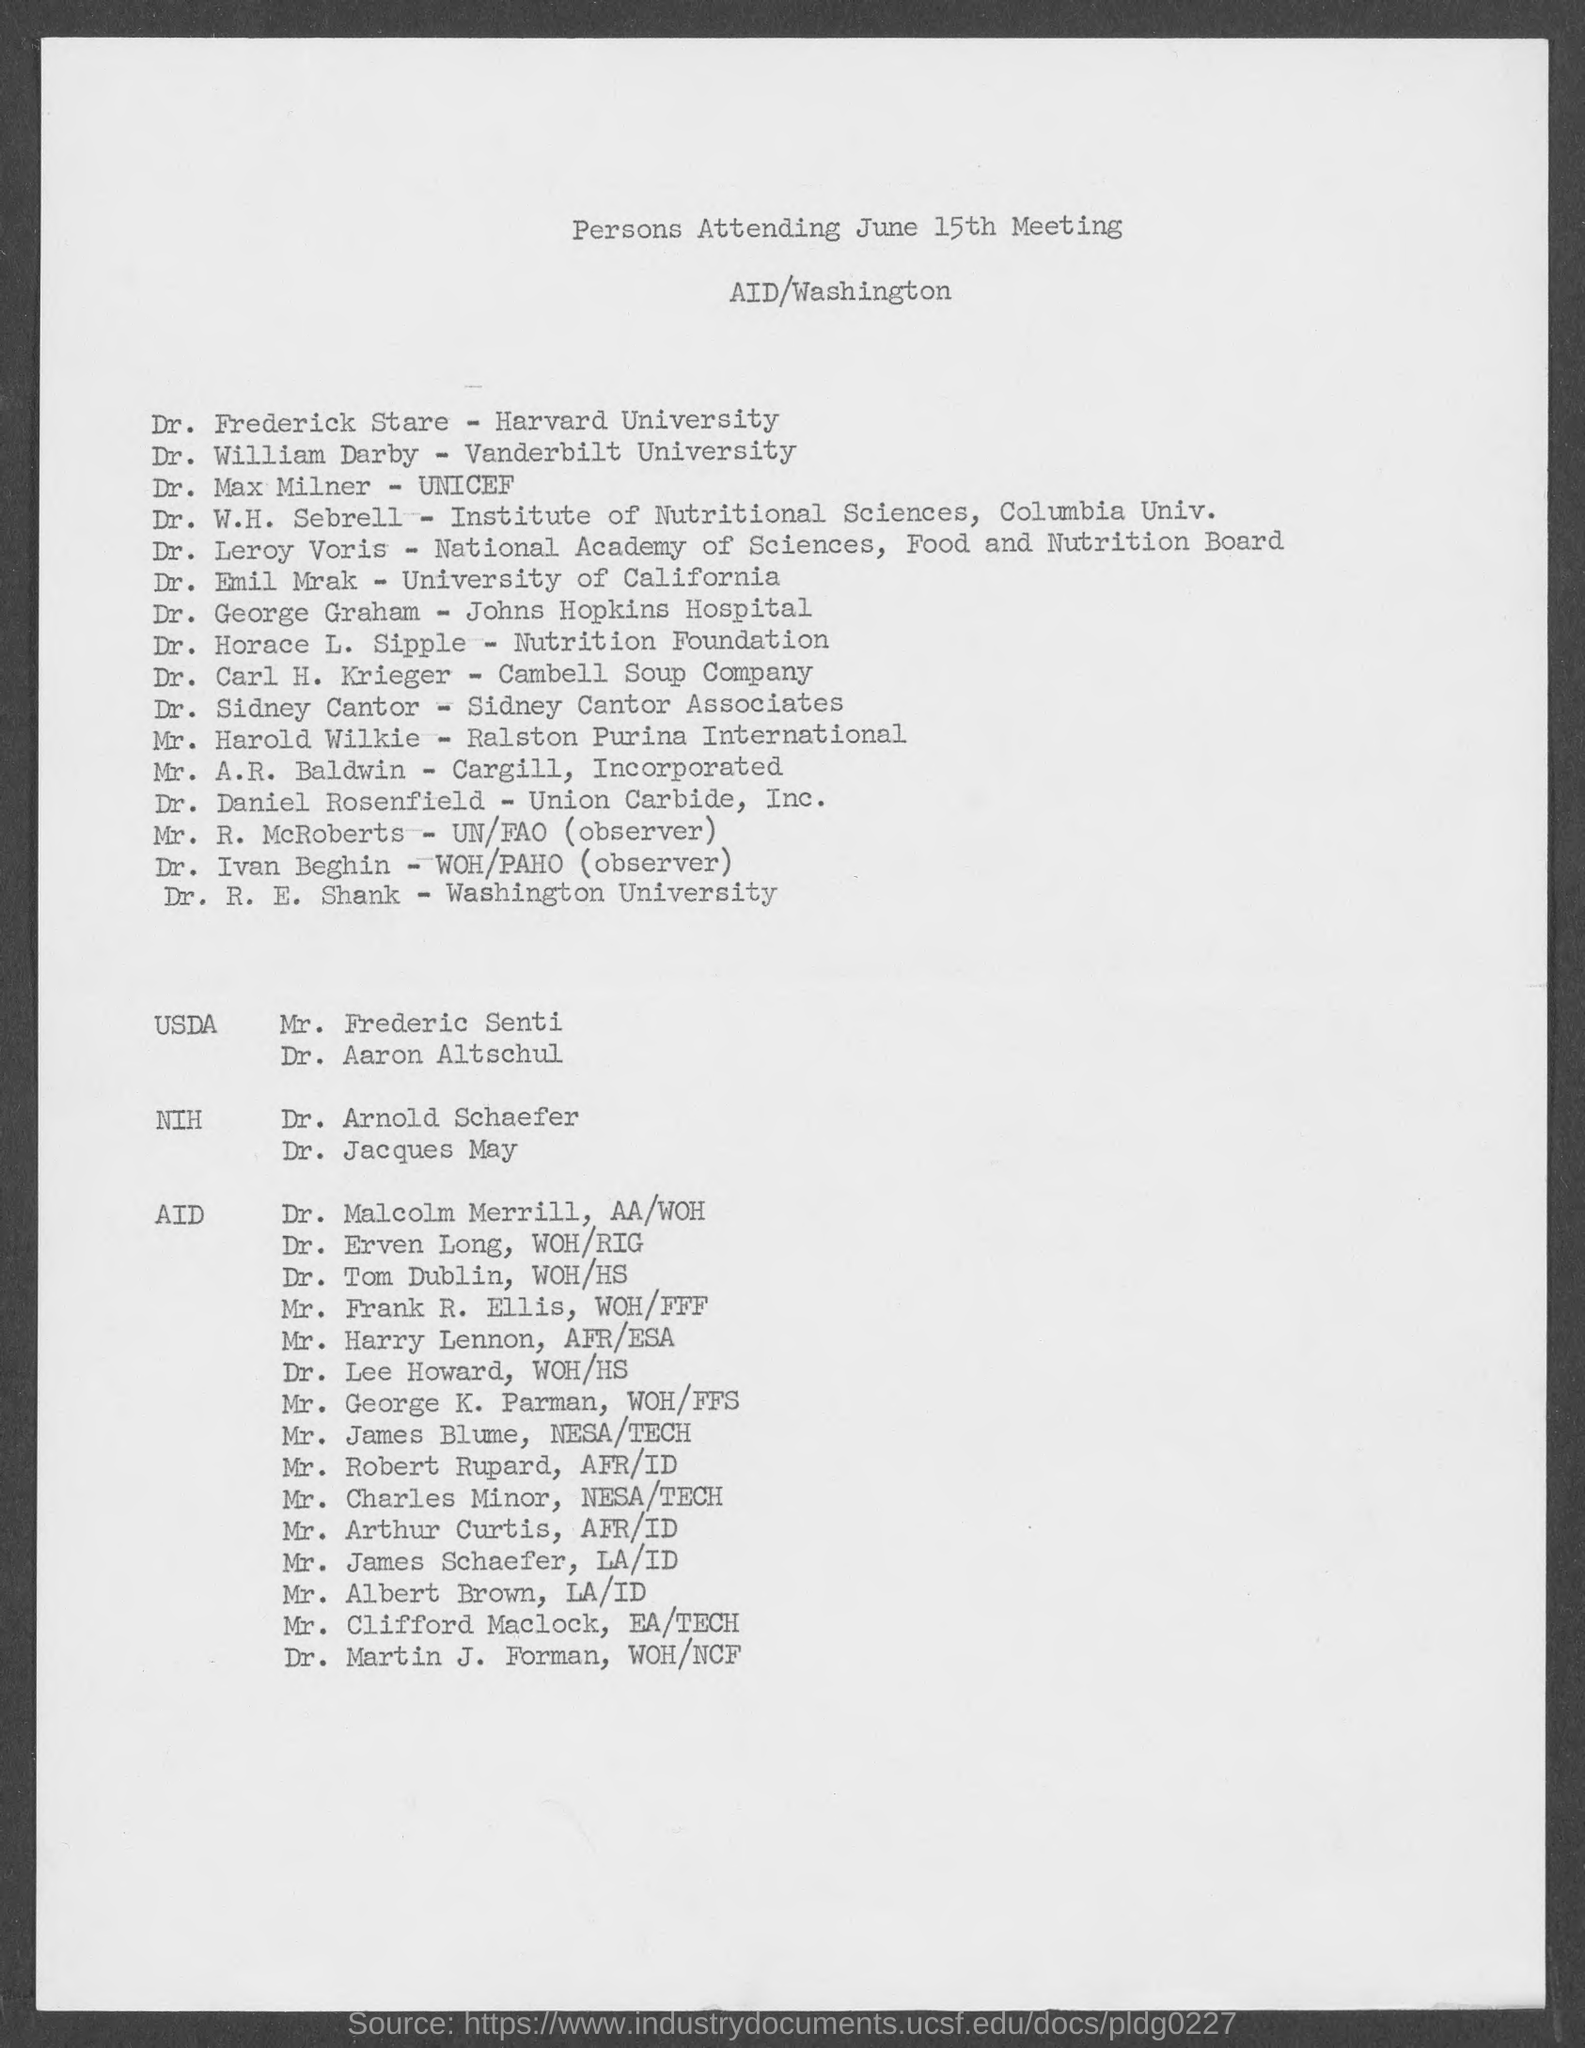What does the document lists?
Your answer should be very brief. Persons attending june 15th meeting. When is the meeting held?
Your answer should be compact. June 15th. Where is the meeting held?
Keep it short and to the point. Aid/washington. Dr. Frederick Stare is from which university?
Provide a short and direct response. Harvard University. Who will be attending the meeting from unicef?
Keep it short and to the point. Dr. Max Milner. 